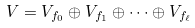Convert formula to latex. <formula><loc_0><loc_0><loc_500><loc_500>V = V _ { f _ { 0 } } \oplus V _ { f _ { 1 } } \oplus \cdots \oplus V _ { f _ { \ell } }</formula> 